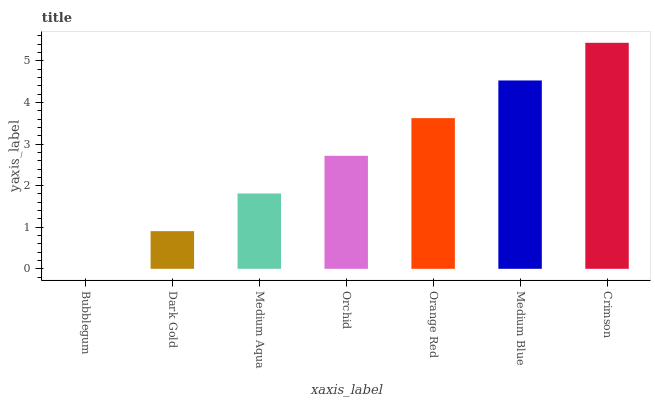Is Bubblegum the minimum?
Answer yes or no. Yes. Is Crimson the maximum?
Answer yes or no. Yes. Is Dark Gold the minimum?
Answer yes or no. No. Is Dark Gold the maximum?
Answer yes or no. No. Is Dark Gold greater than Bubblegum?
Answer yes or no. Yes. Is Bubblegum less than Dark Gold?
Answer yes or no. Yes. Is Bubblegum greater than Dark Gold?
Answer yes or no. No. Is Dark Gold less than Bubblegum?
Answer yes or no. No. Is Orchid the high median?
Answer yes or no. Yes. Is Orchid the low median?
Answer yes or no. Yes. Is Bubblegum the high median?
Answer yes or no. No. Is Medium Blue the low median?
Answer yes or no. No. 